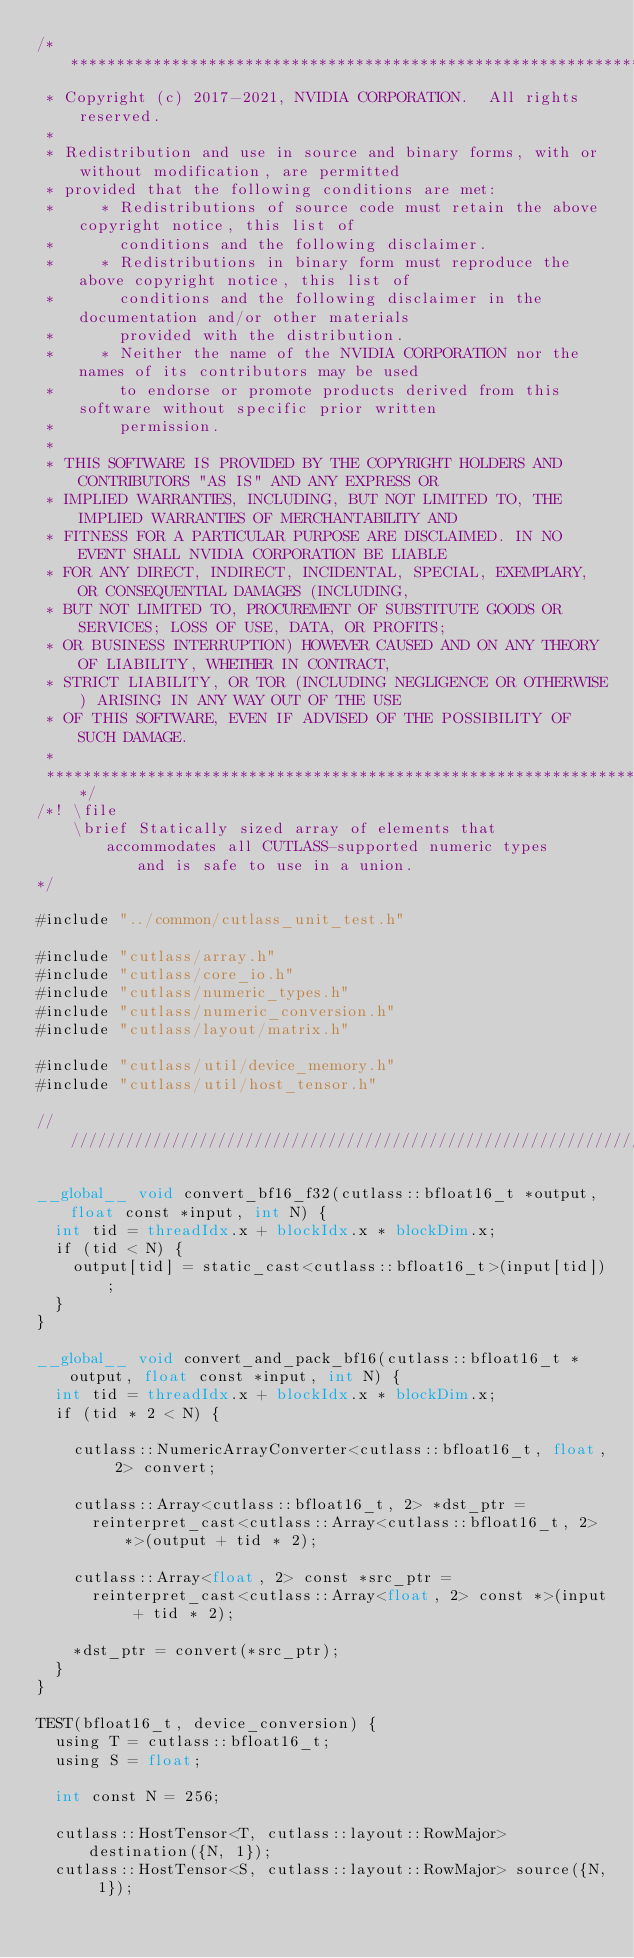Convert code to text. <code><loc_0><loc_0><loc_500><loc_500><_Cuda_>/***************************************************************************************************
 * Copyright (c) 2017-2021, NVIDIA CORPORATION.  All rights reserved.
 *
 * Redistribution and use in source and binary forms, with or without modification, are permitted
 * provided that the following conditions are met:
 *     * Redistributions of source code must retain the above copyright notice, this list of
 *       conditions and the following disclaimer.
 *     * Redistributions in binary form must reproduce the above copyright notice, this list of
 *       conditions and the following disclaimer in the documentation and/or other materials
 *       provided with the distribution.
 *     * Neither the name of the NVIDIA CORPORATION nor the names of its contributors may be used
 *       to endorse or promote products derived from this software without specific prior written
 *       permission.
 *
 * THIS SOFTWARE IS PROVIDED BY THE COPYRIGHT HOLDERS AND CONTRIBUTORS "AS IS" AND ANY EXPRESS OR
 * IMPLIED WARRANTIES, INCLUDING, BUT NOT LIMITED TO, THE IMPLIED WARRANTIES OF MERCHANTABILITY AND
 * FITNESS FOR A PARTICULAR PURPOSE ARE DISCLAIMED. IN NO EVENT SHALL NVIDIA CORPORATION BE LIABLE
 * FOR ANY DIRECT, INDIRECT, INCIDENTAL, SPECIAL, EXEMPLARY, OR CONSEQUENTIAL DAMAGES (INCLUDING,
 * BUT NOT LIMITED TO, PROCUREMENT OF SUBSTITUTE GOODS OR SERVICES; LOSS OF USE, DATA, OR PROFITS;
 * OR BUSINESS INTERRUPTION) HOWEVER CAUSED AND ON ANY THEORY OF LIABILITY, WHETHER IN CONTRACT,
 * STRICT LIABILITY, OR TOR (INCLUDING NEGLIGENCE OR OTHERWISE) ARISING IN ANY WAY OUT OF THE USE
 * OF THIS SOFTWARE, EVEN IF ADVISED OF THE POSSIBILITY OF SUCH DAMAGE.
 *
 **************************************************************************************************/
/*! \file
    \brief Statically sized array of elements that accommodates all CUTLASS-supported numeric types
           and is safe to use in a union.
*/

#include "../common/cutlass_unit_test.h"

#include "cutlass/array.h"
#include "cutlass/core_io.h"
#include "cutlass/numeric_types.h"
#include "cutlass/numeric_conversion.h"
#include "cutlass/layout/matrix.h"

#include "cutlass/util/device_memory.h"
#include "cutlass/util/host_tensor.h"

/////////////////////////////////////////////////////////////////////////////////////////////////

__global__ void convert_bf16_f32(cutlass::bfloat16_t *output, float const *input, int N) {
  int tid = threadIdx.x + blockIdx.x * blockDim.x;
  if (tid < N) {
    output[tid] = static_cast<cutlass::bfloat16_t>(input[tid]);
  }
}

__global__ void convert_and_pack_bf16(cutlass::bfloat16_t *output, float const *input, int N) {
  int tid = threadIdx.x + blockIdx.x * blockDim.x;
  if (tid * 2 < N) {

    cutlass::NumericArrayConverter<cutlass::bfloat16_t, float, 2> convert;

    cutlass::Array<cutlass::bfloat16_t, 2> *dst_ptr = 
      reinterpret_cast<cutlass::Array<cutlass::bfloat16_t, 2> *>(output + tid * 2);

    cutlass::Array<float, 2> const *src_ptr = 
      reinterpret_cast<cutlass::Array<float, 2> const *>(input + tid * 2);

    *dst_ptr = convert(*src_ptr);
  } 
}

TEST(bfloat16_t, device_conversion) {
  using T = cutlass::bfloat16_t;
  using S = float;

  int const N = 256;

  cutlass::HostTensor<T, cutlass::layout::RowMajor> destination({N, 1});
  cutlass::HostTensor<S, cutlass::layout::RowMajor> source({N, 1});
</code> 